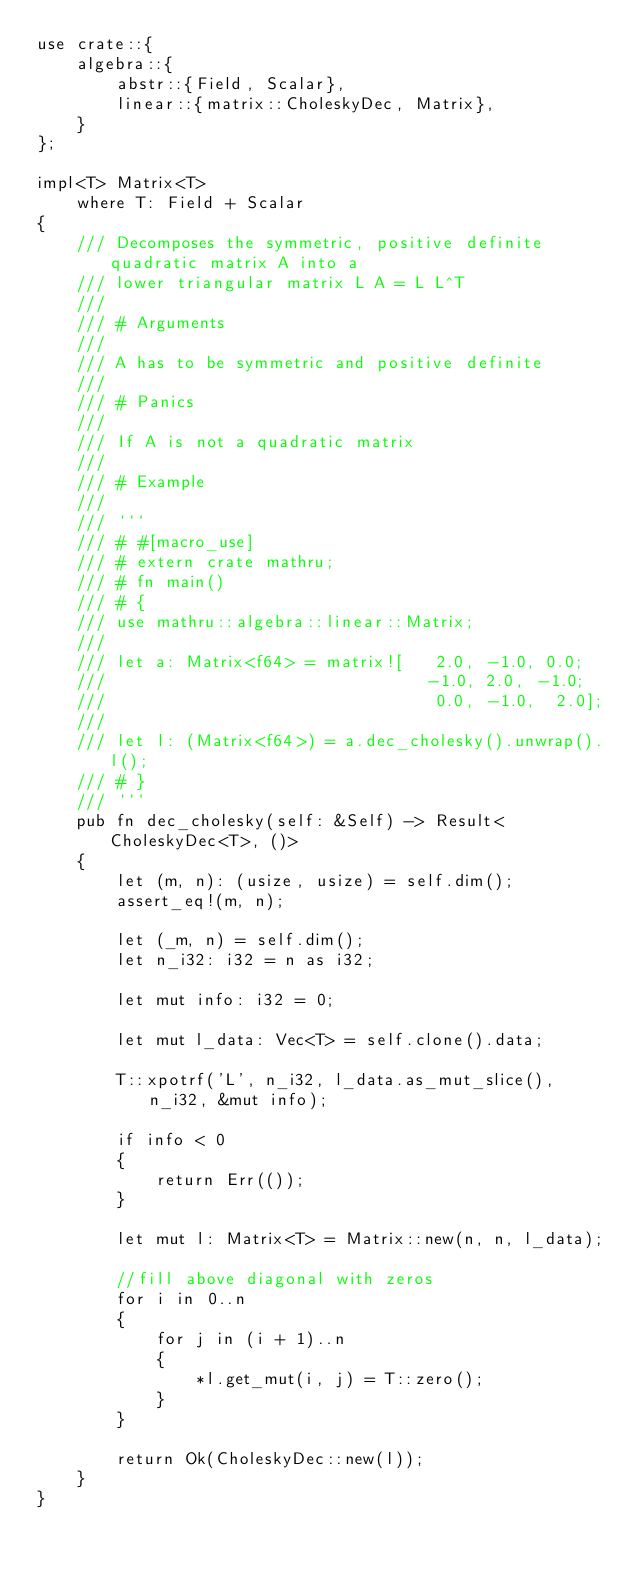<code> <loc_0><loc_0><loc_500><loc_500><_Rust_>use crate::{
    algebra::{
        abstr::{Field, Scalar},
        linear::{matrix::CholeskyDec, Matrix},
    }
};

impl<T> Matrix<T>
    where T: Field + Scalar
{
    /// Decomposes the symmetric, positive definite quadratic matrix A into a
    /// lower triangular matrix L A = L L^T
    ///
    /// # Arguments
    ///
    /// A has to be symmetric and positive definite
    ///
    /// # Panics
    ///
    /// If A is not a quadratic matrix
    ///
    /// # Example
    ///
    /// ```
    /// # #[macro_use]
    /// # extern crate mathru;
    /// # fn main()
    /// # {
    /// use mathru::algebra::linear::Matrix;
    ///
    /// let a: Matrix<f64> = matrix![   2.0, -1.0, 0.0;
    ///                                -1.0, 2.0, -1.0;
    ///                                 0.0, -1.0,  2.0];
    ///
    /// let l: (Matrix<f64>) = a.dec_cholesky().unwrap().l();
    /// # }
    /// ```
    pub fn dec_cholesky(self: &Self) -> Result<CholeskyDec<T>, ()>
    {
        let (m, n): (usize, usize) = self.dim();
        assert_eq!(m, n);

        let (_m, n) = self.dim();
        let n_i32: i32 = n as i32;

        let mut info: i32 = 0;

        let mut l_data: Vec<T> = self.clone().data;

        T::xpotrf('L', n_i32, l_data.as_mut_slice(), n_i32, &mut info);

        if info < 0
        {
            return Err(());
        }

        let mut l: Matrix<T> = Matrix::new(n, n, l_data);

        //fill above diagonal with zeros
        for i in 0..n
        {
            for j in (i + 1)..n
            {
                *l.get_mut(i, j) = T::zero();
            }
        }

        return Ok(CholeskyDec::new(l));
    }
}
</code> 